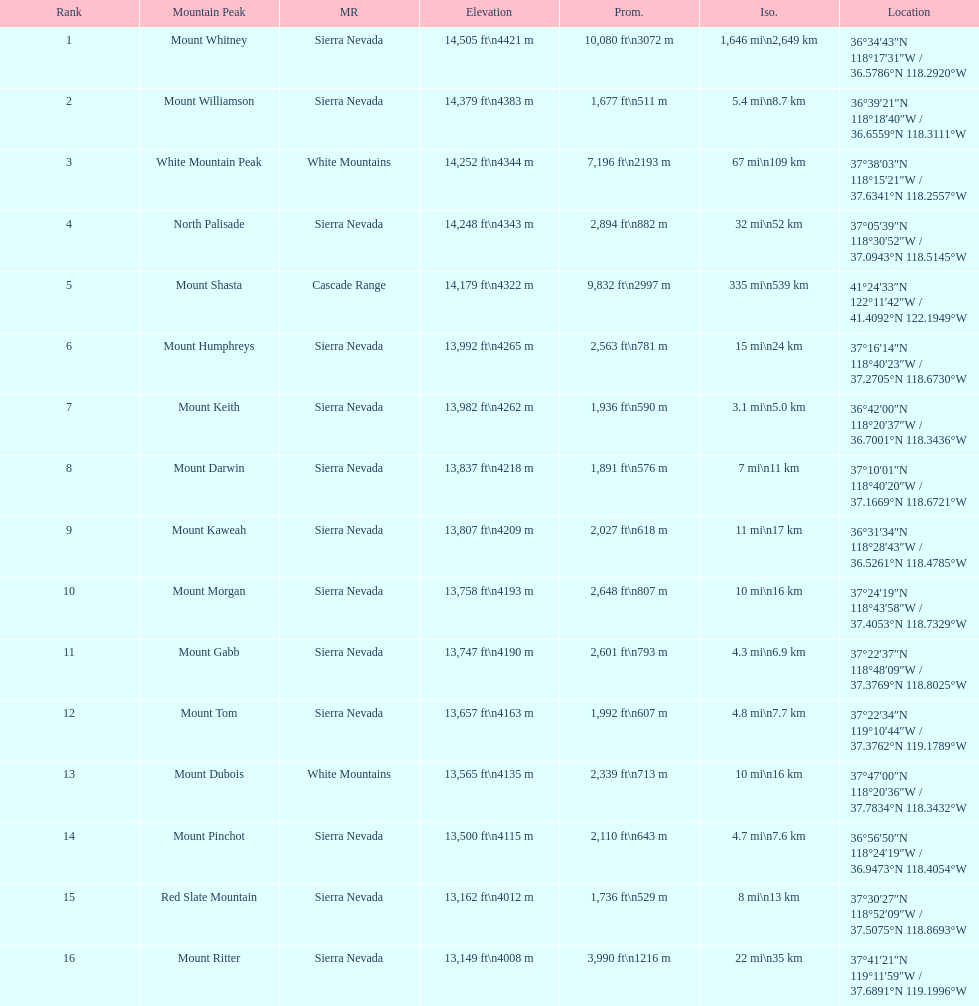Which mountain peak has a prominence more than 10,000 ft? Mount Whitney. 